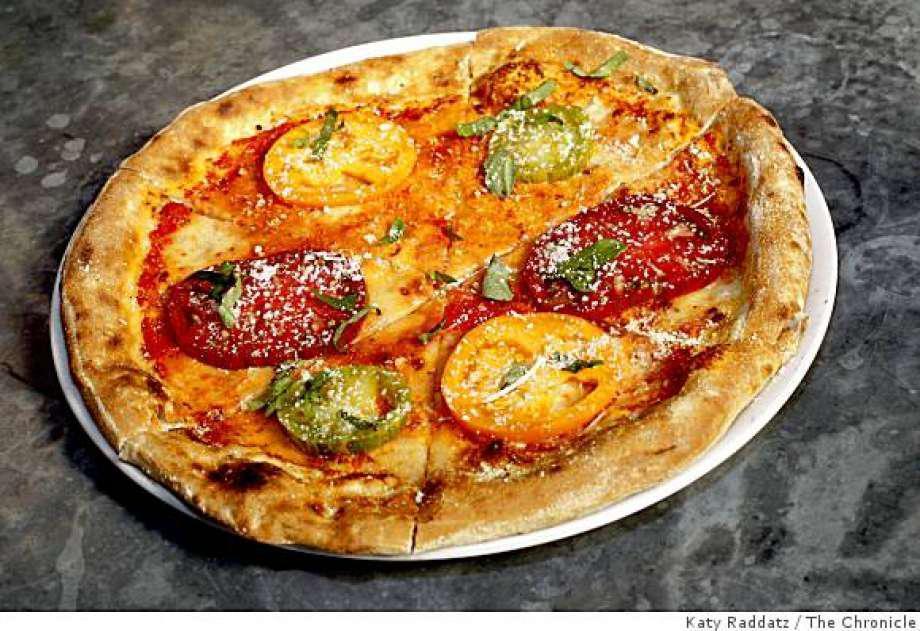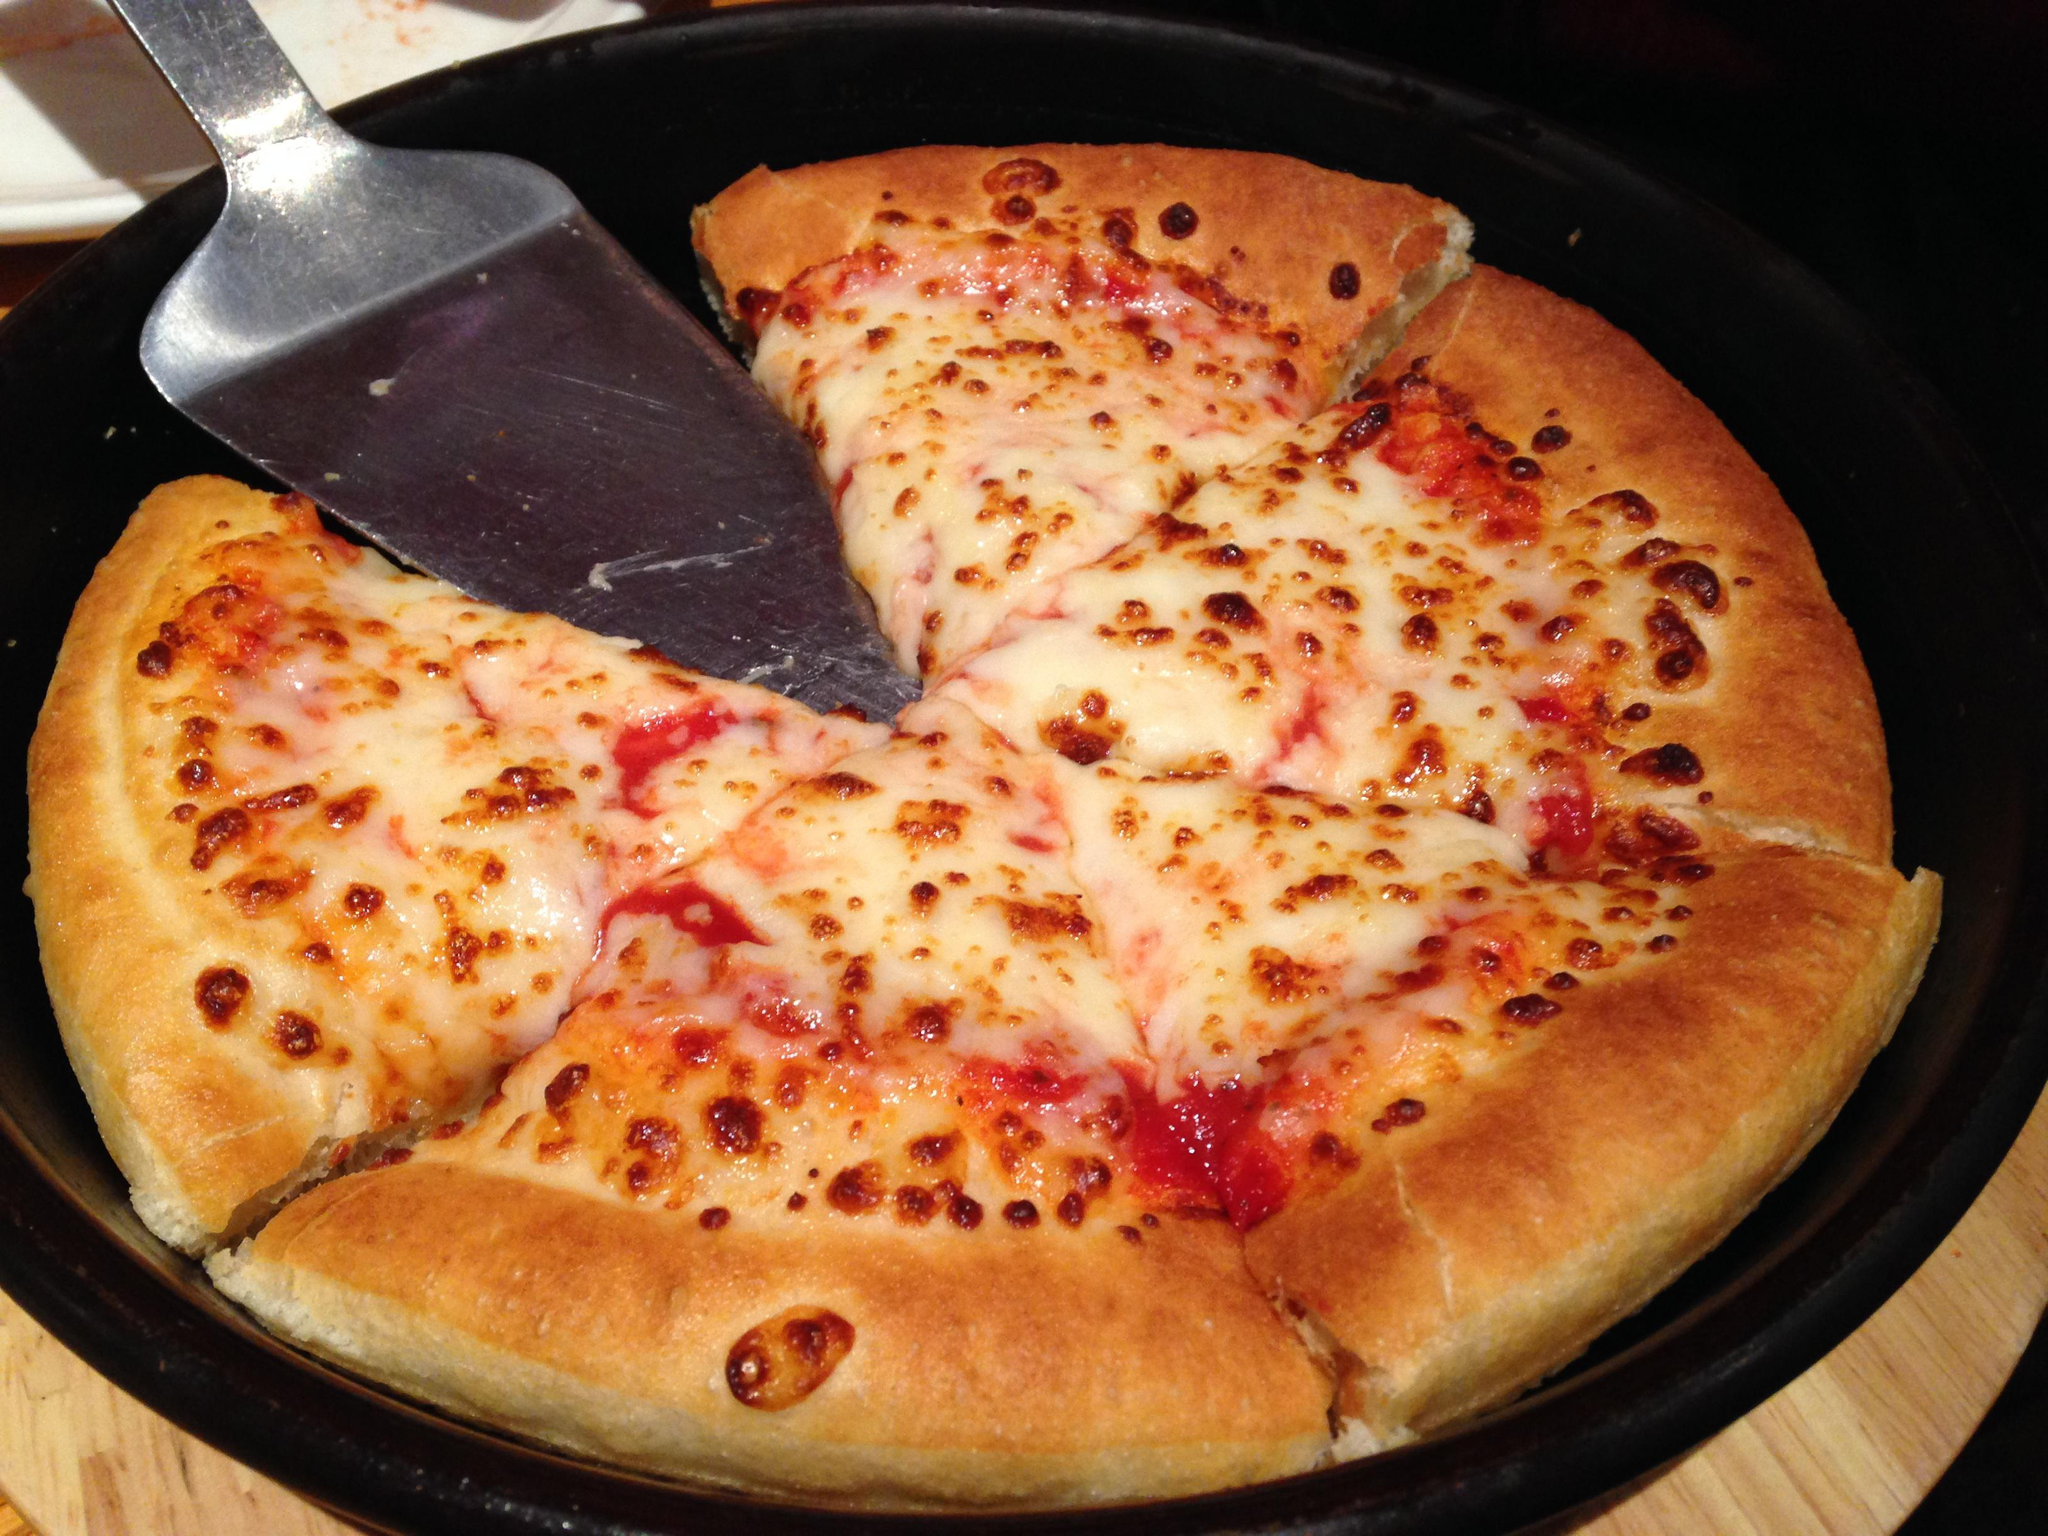The first image is the image on the left, the second image is the image on the right. Evaluate the accuracy of this statement regarding the images: "One of the pizzas has hamburgers on top.". Is it true? Answer yes or no. No. The first image is the image on the left, the second image is the image on the right. For the images displayed, is the sentence "A pizza is topped with burgers, fries and nuggets." factually correct? Answer yes or no. No. 